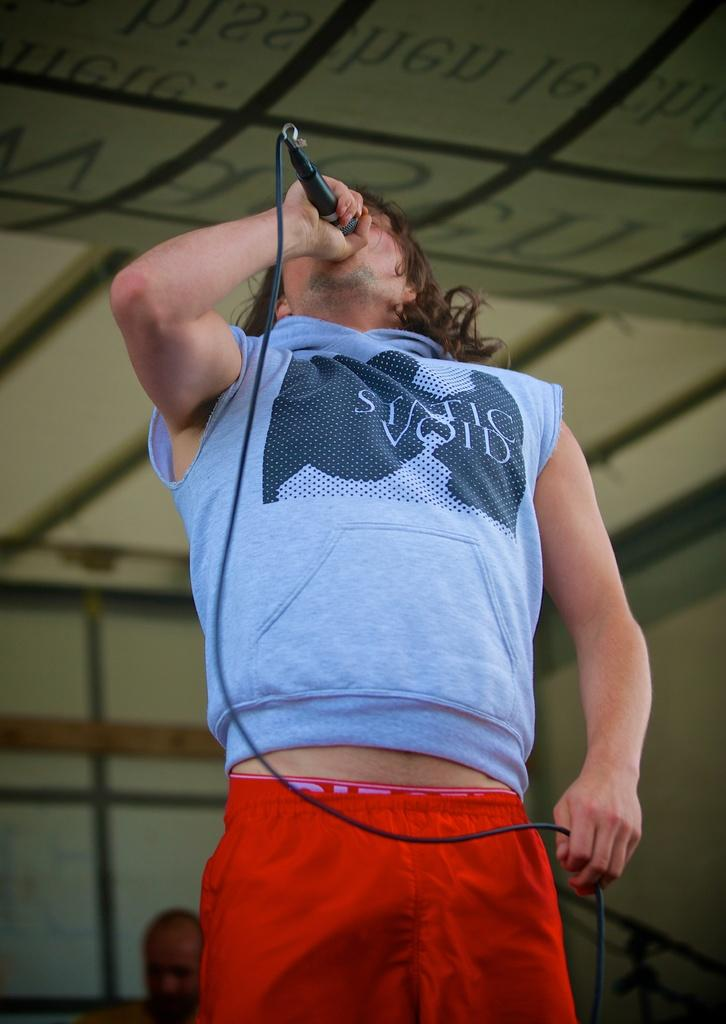<image>
Describe the image concisely. A man in a shirt that says Static Void on the front. 